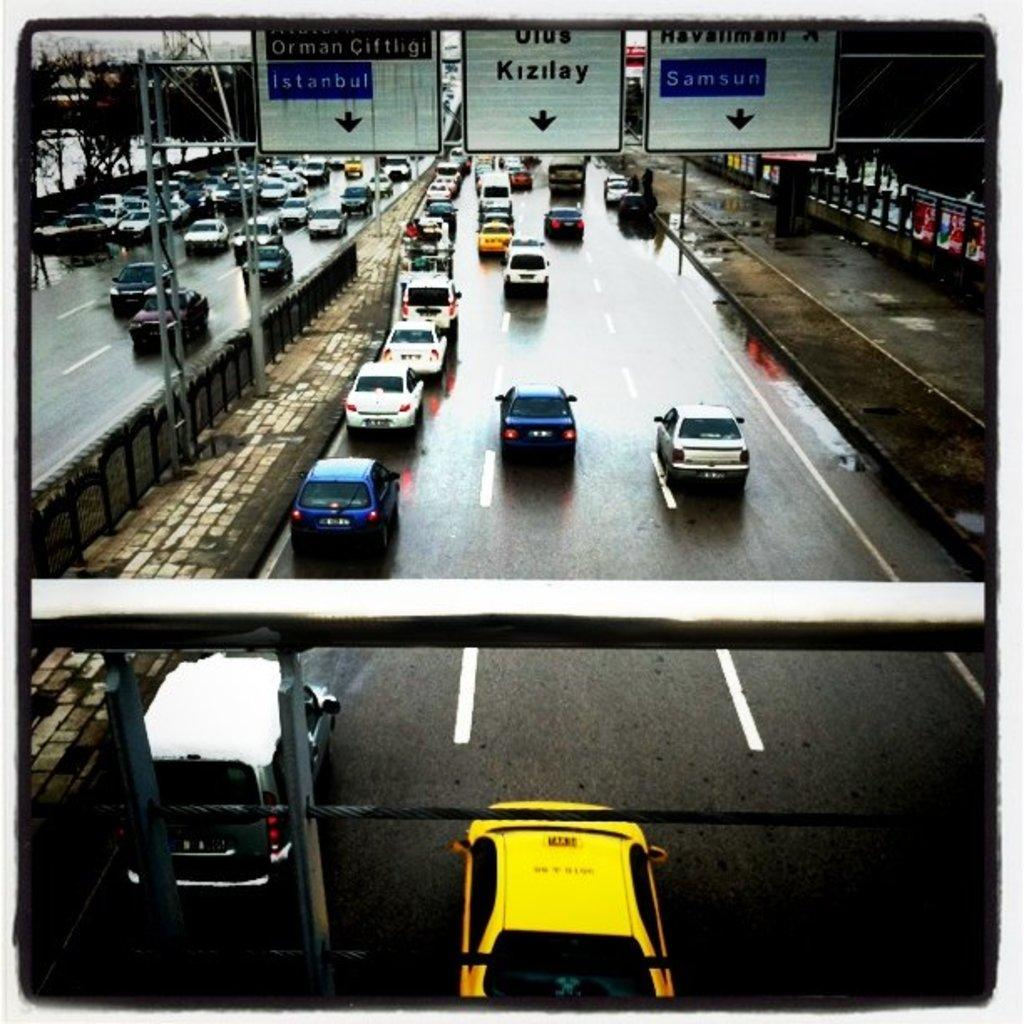What can be seen moving on the roads in the image? There are vehicles on the road in the image. What type of surface can be seen in the image? There are roads visible in the image. What kind of signs are present in the image? There are boards with text in the image. What safety feature is present in the image? There are railings in the image. What type of natural elements are present in the image? There are plants in the image. What type of marble is used for the railings in the image? There is no marble present in the image; the railings are made of a different material. What is your opinion on the hobbies of the people in the image? The image does not show any people or their hobbies, so it is impossible to provide an opinion on them. 